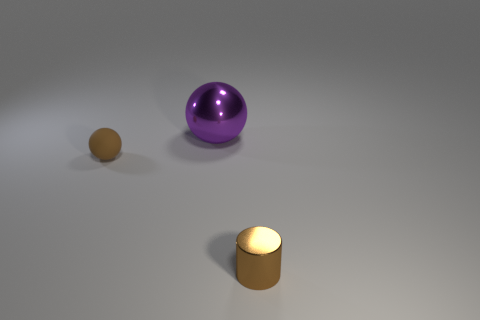Add 1 small brown cylinders. How many objects exist? 4 Subtract all cylinders. How many objects are left? 2 Subtract 0 green cylinders. How many objects are left? 3 Subtract all brown rubber objects. Subtract all large blue shiny cubes. How many objects are left? 2 Add 1 tiny brown spheres. How many tiny brown spheres are left? 2 Add 3 tiny red balls. How many tiny red balls exist? 3 